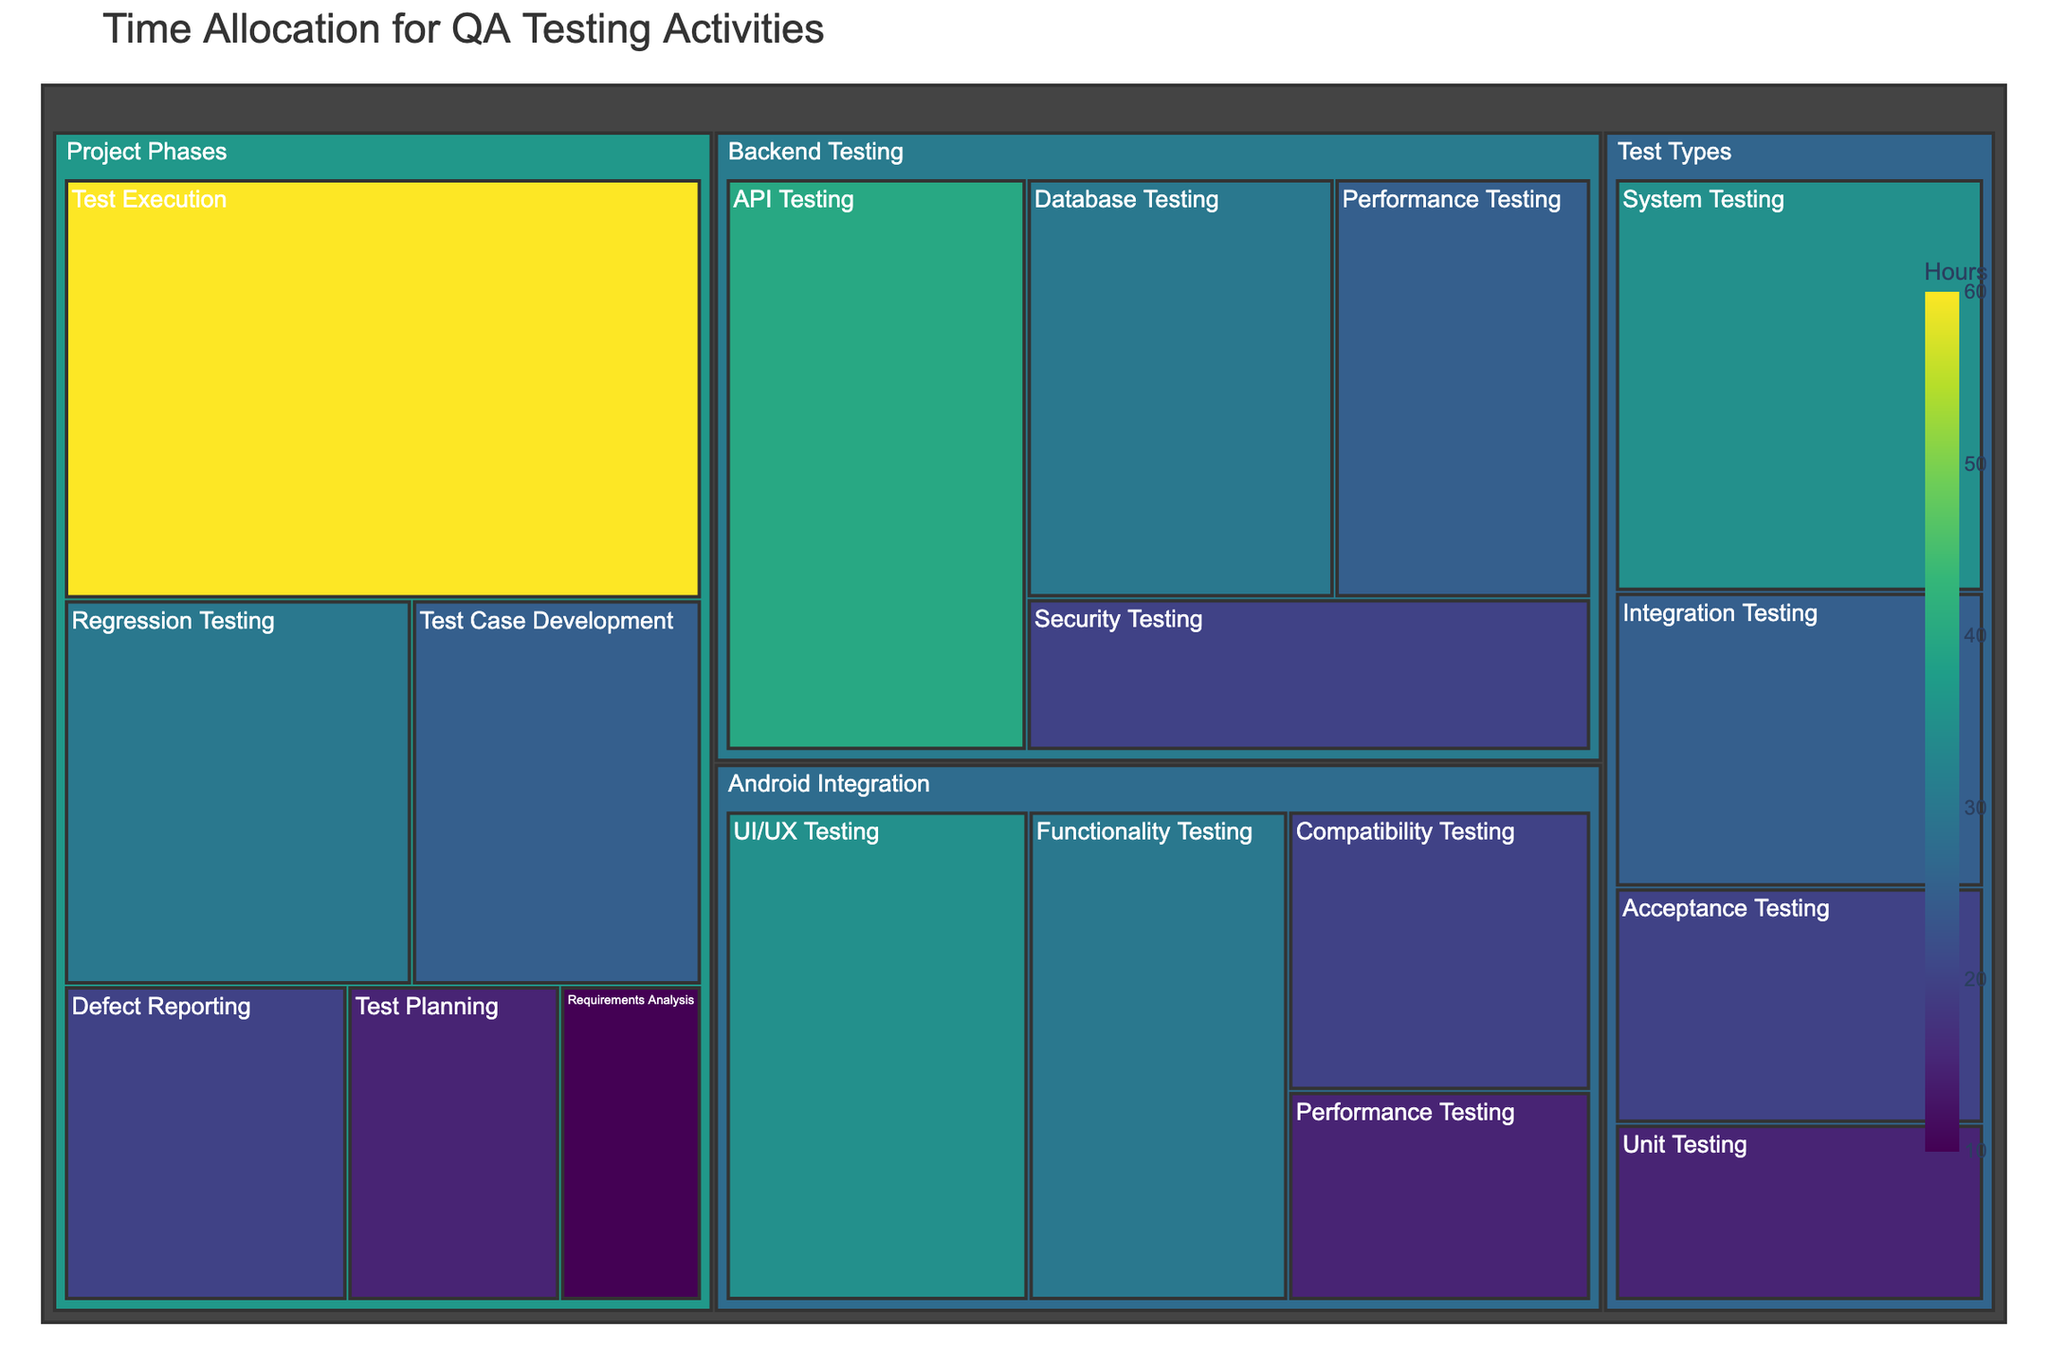What is the total time allocated to Backend Testing? Sum the times of all subcategories under Backend Testing: 40 + 30 + 25 + 20 = 115 hours.
Answer: 115 hours Which subcategory under Android Integration has the highest time allocation? Compare the time allocations for all subcategories under Android Integration: UI/UX Testing (35), Functionality Testing (30), Compatibility Testing (20), Performance Testing (15). UI/UX Testing has the highest time allocation.
Answer: UI/UX Testing How much more time is spent on Test Execution compared to Regression Testing in the Project Phases category? Find the time allocations for Test Execution (60 hours) and Regression Testing (30 hours). Then, subtract the time of Regression Testing from Test Execution: 60 - 30 = 30 hours.
Answer: 30 hours What is the combined time allocated to Performance Testing in both Backend Testing and Android Integration? Sum the times for Performance Testing under both categories: Backend Testing (25 hours) + Android Integration (15 hours) = 40 hours.
Answer: 40 hours Which test type has the least amount of time allocated? Compare the time allocations for all test types: Unit Testing (15), Integration Testing (25), System Testing (35), Acceptance Testing (20). Unit Testing has the least time allocation.
Answer: Unit Testing What is the difference in time allocation between Database Testing and Security Testing in Backend Testing? Find the time allocations for Database Testing (30 hours) and Security Testing (20 hours). Then, subtract Security Testing from Database Testing: 30 - 20 = 10 hours.
Answer: 10 hours What is the average time allocated to activities under Test Types? Sum the times for all activities under Test Types: 15 + 25 + 35 + 20 = 95 hours. Divide by the number of activities (4): 95 / 4 = 23.75 hours.
Answer: 23.75 hours Which category has the highest total time allocation? Sum the times for each category: Backend Testing (40 + 30 + 25 + 20 = 115), Android Integration (35 + 30 + 20 + 15 = 100), Project Phases (10 + 15 + 25 + 60 + 20 + 30 = 160), Test Types (15 + 25 + 35 + 20 = 95). Project Phases has the highest total time allocation.
Answer: Project Phases What is the proportion of time spent on Functionality Testing under Android Integration compared to the total time for Android Integration? Find the time for Functionality Testing (30 hours) and the total time for Android Integration (100 hours). Then, divide Functionality Testing time by the total: 30 / 100 = 0.3 or 30%.
Answer: 30% How many subcategories are there in total across all the categories? Count the subcategories under each category: Backend Testing (4), Android Integration (4), Project Phases (6), Test Types (4). Sum them up: 4 + 4 + 6 + 4 = 18 subcategories.
Answer: 18 subcategories 